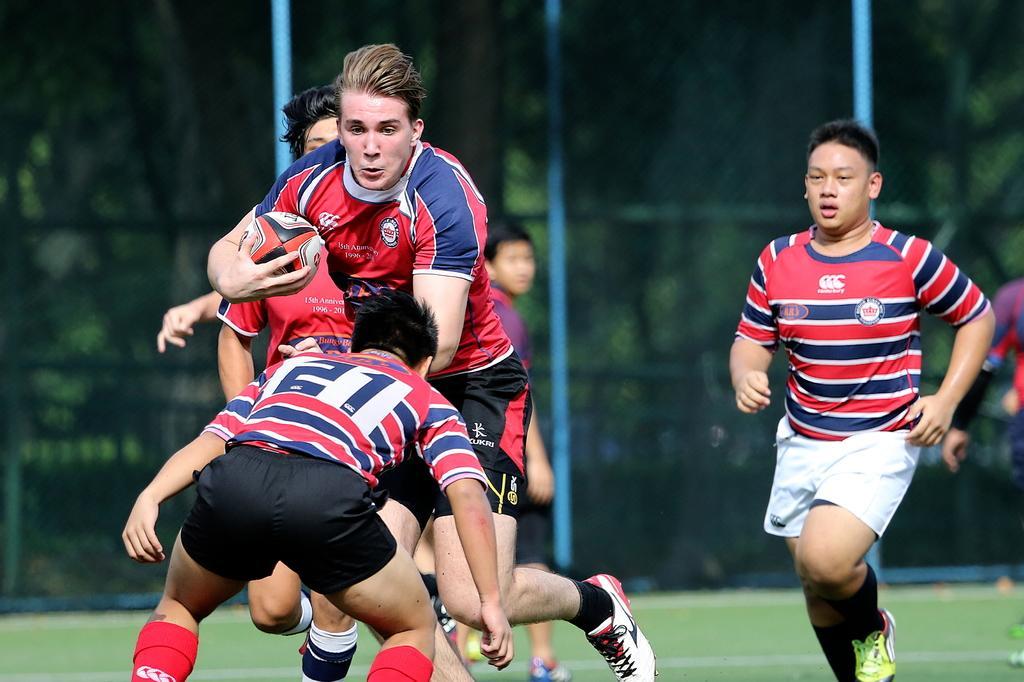Describe this image in one or two sentences. This picture describe about the four boys who are playing foot game, On the right a boy running forward wearing red and blue strip t- shirt, white shorts and green shoe, Middle a boy is jumping with ball and in the front a boy wants to stop. 